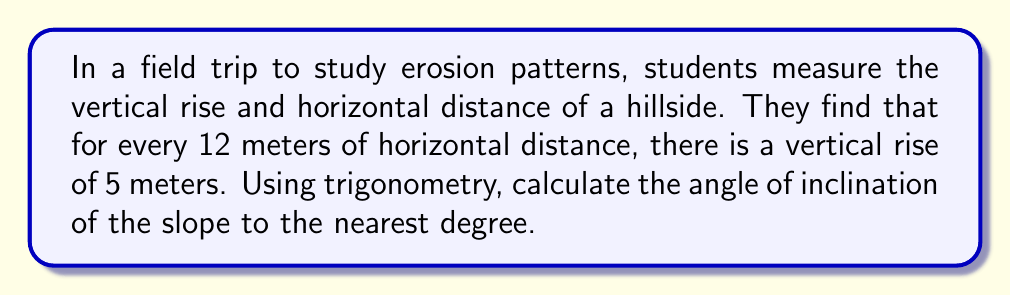Can you answer this question? Let's approach this step-by-step:

1) In this scenario, we have a right-angled triangle where:
   - The adjacent side (horizontal distance) is 12 meters
   - The opposite side (vertical rise) is 5 meters
   - The angle of inclination is what we're looking for

2) To find the angle of inclination, we can use the tangent function:

   $$\tan(\theta) = \frac{\text{opposite}}{\text{adjacent}}$$

3) Substituting our values:

   $$\tan(\theta) = \frac{5}{12}$$

4) To find $\theta$, we need to use the inverse tangent (arctan or $\tan^{-1}$):

   $$\theta = \tan^{-1}(\frac{5}{12})$$

5) Using a calculator or computer:

   $$\theta \approx 22.62°$$

6) Rounding to the nearest degree:

   $$\theta \approx 23°$$

This method demonstrates how trigonometry can be applied to real-world scenarios in earth science, such as measuring hillside inclinations for erosion studies.
Answer: $23°$ 